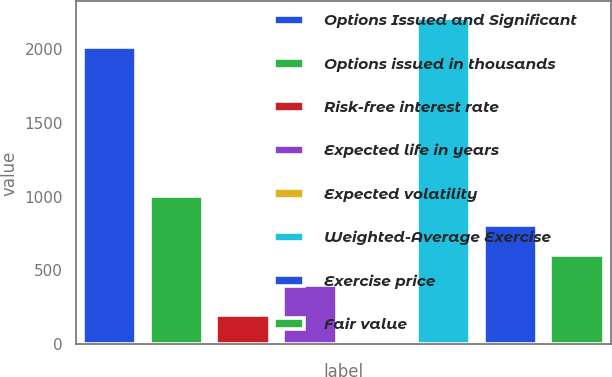Convert chart to OTSL. <chart><loc_0><loc_0><loc_500><loc_500><bar_chart><fcel>Options Issued and Significant<fcel>Options issued in thousands<fcel>Risk-free interest rate<fcel>Expected life in years<fcel>Expected volatility<fcel>Weighted-Average Exercise<fcel>Exercise price<fcel>Fair value<nl><fcel>2010<fcel>1005.12<fcel>201.24<fcel>402.21<fcel>0.27<fcel>2210.97<fcel>804.15<fcel>603.18<nl></chart> 